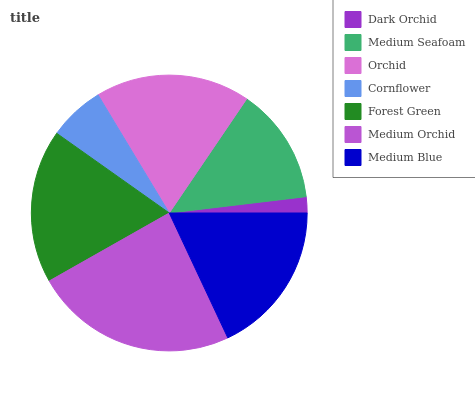Is Dark Orchid the minimum?
Answer yes or no. Yes. Is Medium Orchid the maximum?
Answer yes or no. Yes. Is Medium Seafoam the minimum?
Answer yes or no. No. Is Medium Seafoam the maximum?
Answer yes or no. No. Is Medium Seafoam greater than Dark Orchid?
Answer yes or no. Yes. Is Dark Orchid less than Medium Seafoam?
Answer yes or no. Yes. Is Dark Orchid greater than Medium Seafoam?
Answer yes or no. No. Is Medium Seafoam less than Dark Orchid?
Answer yes or no. No. Is Forest Green the high median?
Answer yes or no. Yes. Is Forest Green the low median?
Answer yes or no. Yes. Is Medium Blue the high median?
Answer yes or no. No. Is Dark Orchid the low median?
Answer yes or no. No. 